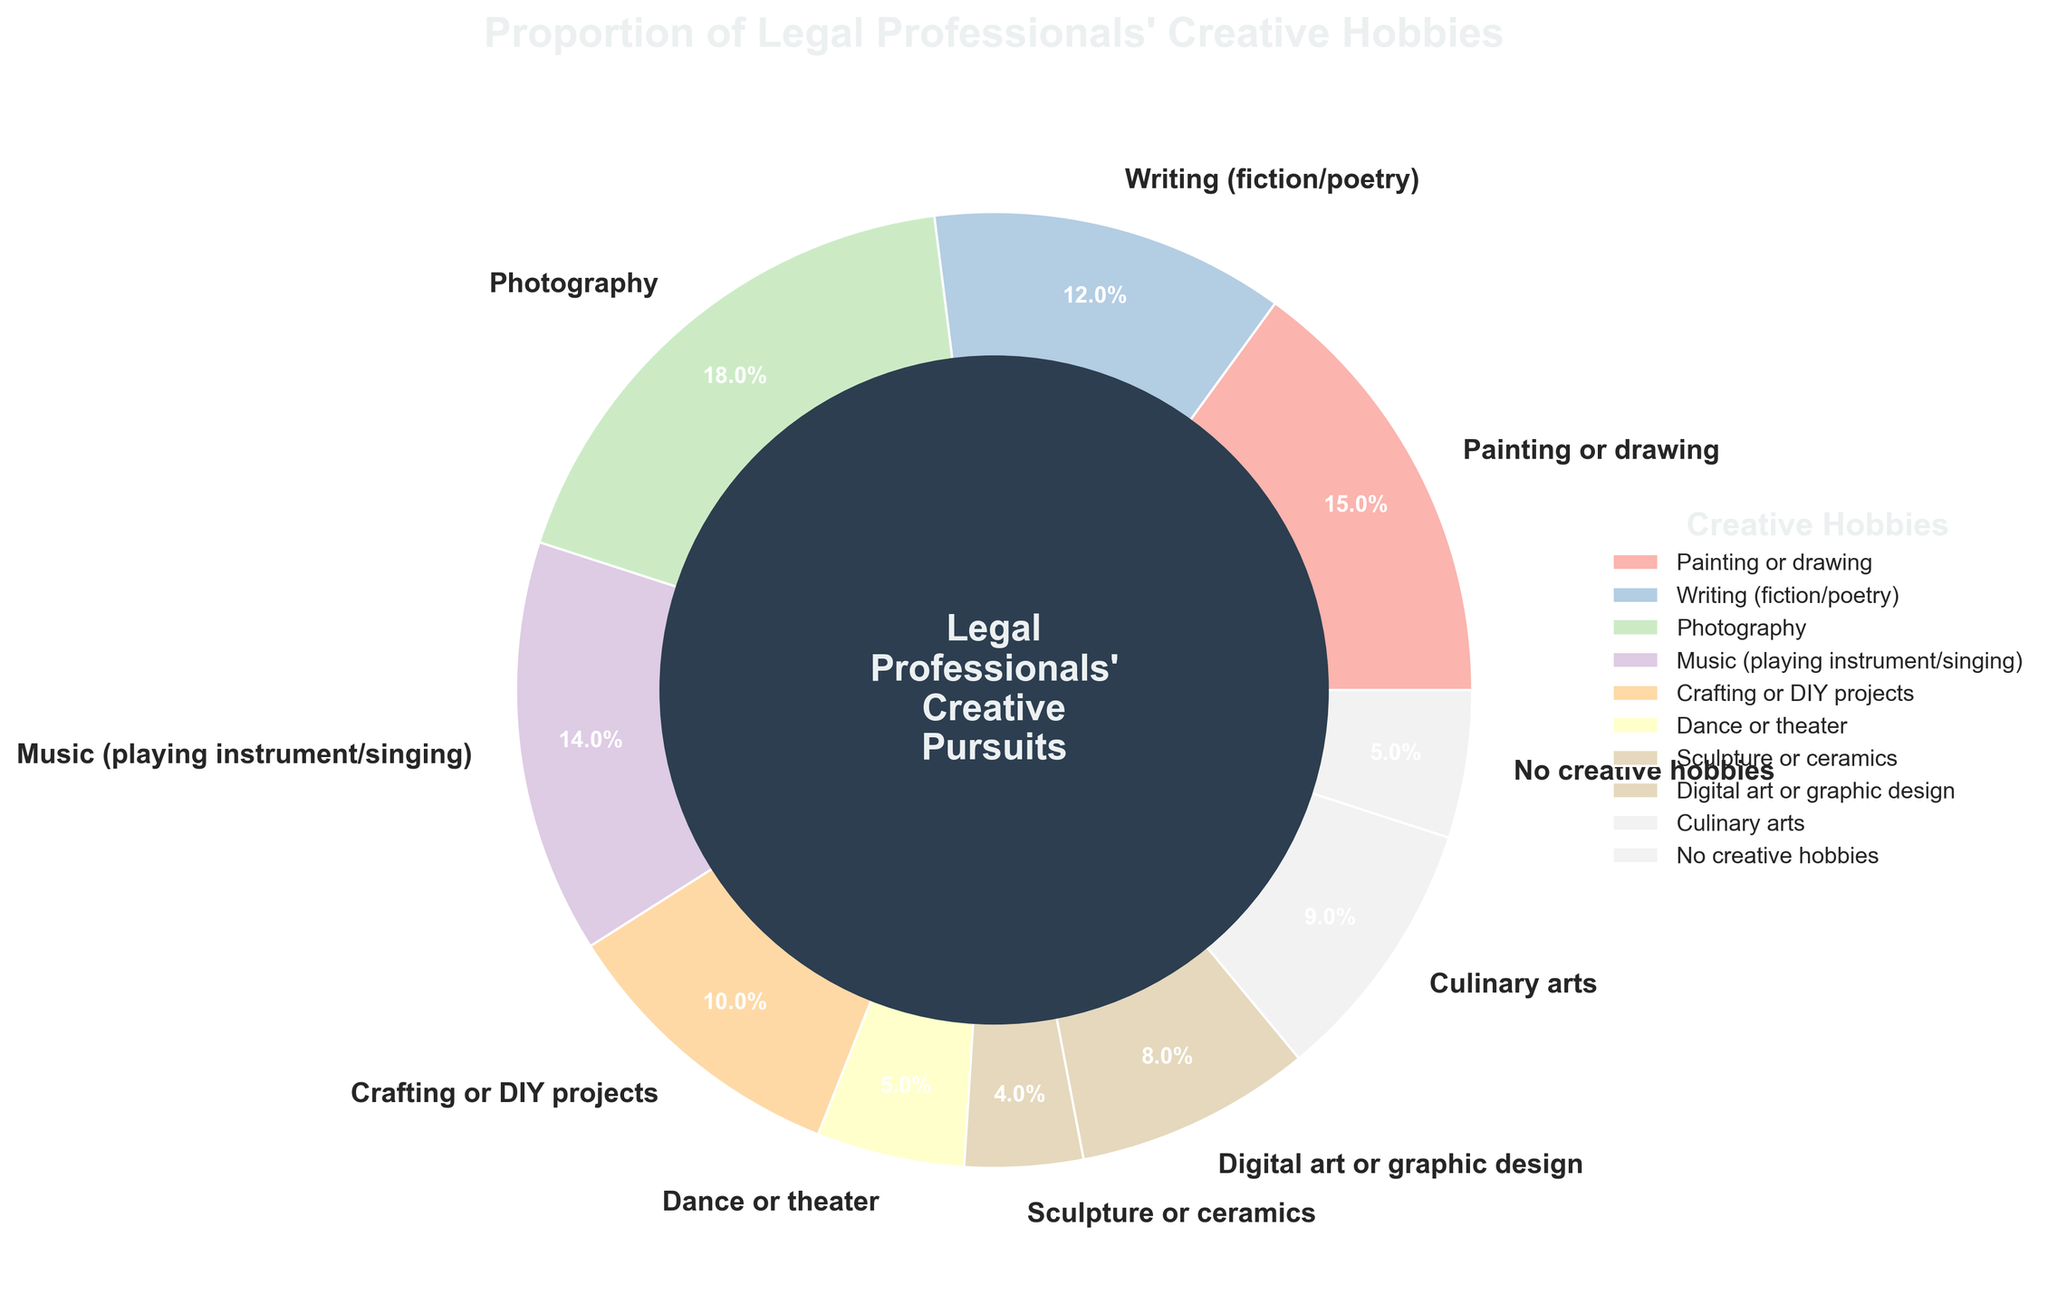Which category has the largest proportion of legal professionals engaging in it? By examining the pie chart, it is evident which section occupies the largest area. The largest segment corresponds to 'Photography', as marked by its label and percentage value.
Answer: Photography Which two categories combined make up less than 10% of the total? Identify the categories and their respective percentage values from the chart. Select two whose sum is less than 10%. 'Dance or theater' (5%) and 'Sculpture or ceramics' (4%) together add up to 9%.
Answer: Dance or theater, Sculpture or ceramics How does the proportion of legal professionals involved in crafting compare to those involved in digital art? Compare the sizes of the pie sections for 'Crafting or DIY projects' and 'Digital art or graphic design'. Crafting or DIY projects has a segment representing 10%, while Digital art or graphic design has a segment representing 8%.
Answer: Crafting or DIY projects has a larger proportion Are there any categories with an equal proportion of legal professionals involved? Go through each segment and compare their percentage values. Both 'Dance or theater' and 'No creative hobbies' have segments representing 5%.
Answer: Yes, Dance or theater and No creative hobbies What visual element highlights the title of the chart? Look for distinctive visual features around the chart's title. The title is at the top of the chart, highlighted with a larger font size, bold font weight, and a specific color (#ECF0F1).
Answer: Larger, bold, color What is the combined percentage of legal professionals involved in activities related to the visual arts (painting, photography, sculpture, digital art)? Sum the percentages from the visual arts-related categories: 'Painting or drawing' (15%), 'Photography' (18%), 'Sculpture or ceramics' (4%), 'Digital art or graphic design' (8%). The total is 15% + 18% + 4% + 8%.
Answer: 45% Is the proportion of legal professionals with no creative hobbies higher than those involved in dance or theater? Compare the segments for 'No creative hobbies' and 'Dance or theater'. Both segments are equal, each representing 5%.
Answer: No, they are equal Which category is the smallest, and what percentage does it represent? Identify the smallest section of the pie chart and look at its label. The 'Sculpture or ceramics' segment is the smallest, representing 4%.
Answer: Sculpture or ceramics, 4% What percentage of legal professionals are involved in writing as compared to music? Compare the segments labeled 'Writing (fiction/poetry)' and 'Music (playing instrument/singing)'. Writing has a segment representing 12%, and Music has a segment representing 14%.
Answer: Writing is 2% less than Music 